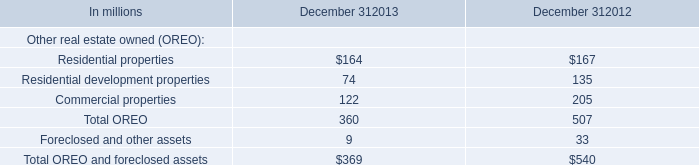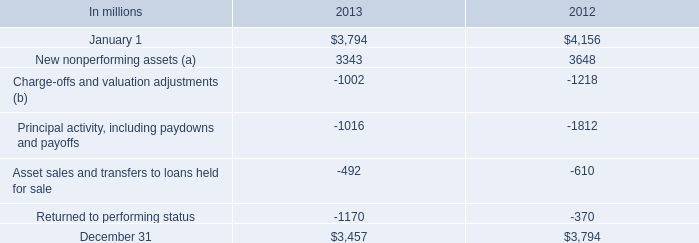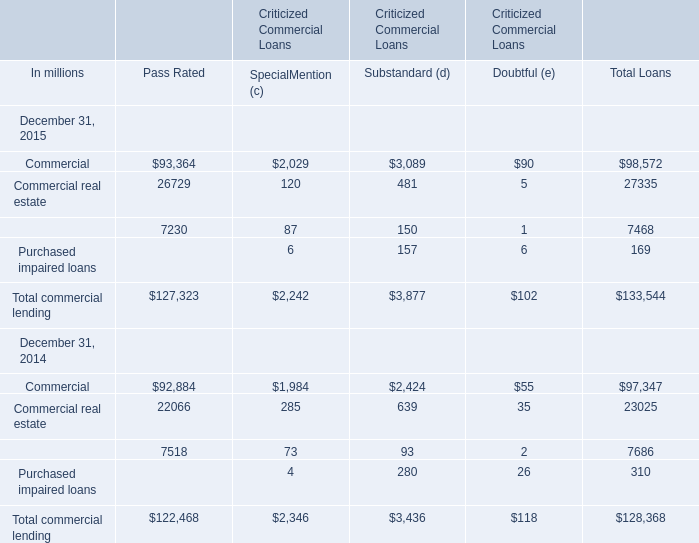What was the average value of Special Mention(c), Substandard (d), Doubtful (e) in 2015 of Total commercial lending? (in million) 
Computations: (((2242 + 3877) + 102) / 3)
Answer: 2073.66667. 